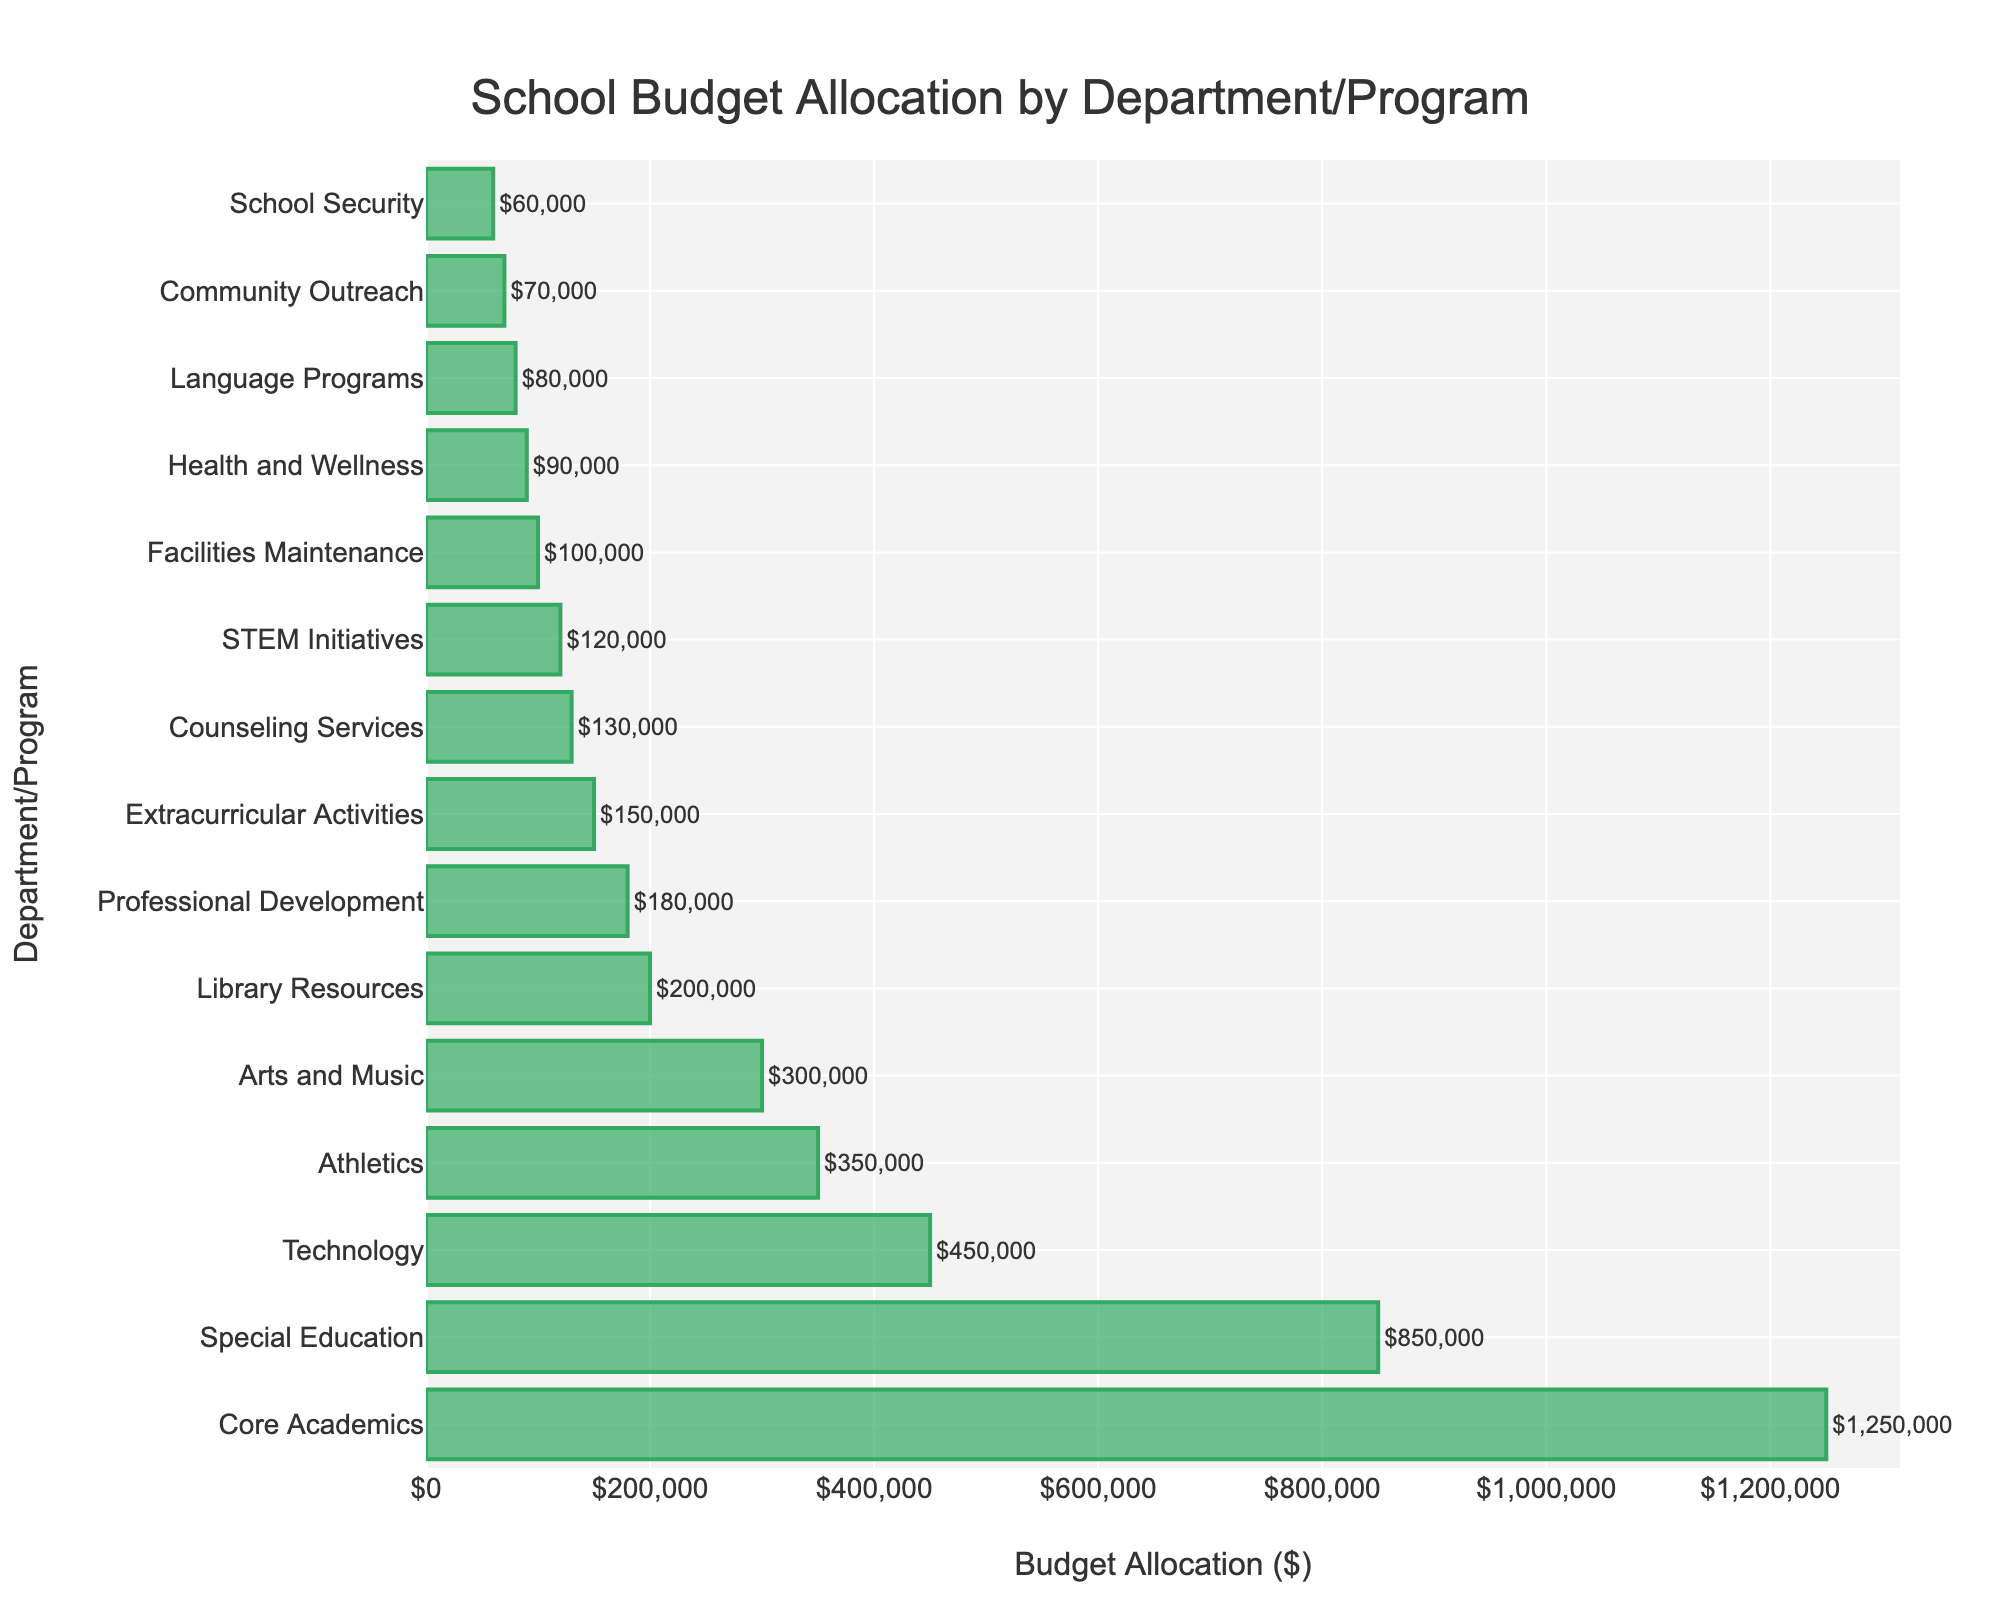Which department received the highest budget allocation? The department with the highest budget allocation is the one with the longest bar in the bar chart. The Core Academics department has the longest bar.
Answer: Core Academics How much is allocated to Special Education compared to Technology? To find out how much more is allocated, subtract the budget for Technology from the budget for Special Education: 850,000 - 450,000 = 400,000.
Answer: 400,000 What's the total budget allocated to Arts and Music, Library Resources, and Professional Development? Add the budget allocations for these departments: 300,000 + 200,000 + 180,000 = 680,000.
Answer: 680,000 Which department has the smallest budget allocation? The department with the smallest budget allocation is the one with the shortest bar in the bar chart. The School Security department has the shortest bar.
Answer: School Security What is the difference in budget allocation between Athletics and Extracurricular Activities? Subtract the budget for Extracurricular Activities from the budget for Athletics: 350,000 - 150,000 = 200,000.
Answer: 200,000 Is the budget allocation for Health and Wellness greater than Language Programs? Compare the lengths of the bars for Health and Wellness and Language Programs. Health and Wellness has a longer bar, indicating a higher budget allocation.
Answer: Yes What is the combined budget for STEM Initiatives and Community Outreach? Add the budget allocations for these departments: 120,000 + 70,000 = 190,000.
Answer: 190,000 How does the budget for Counseling Services compare to Library Resources? Compare the lengths of the bars for Counseling Services (130,000) and Library Resources (200,000). Counseling Services has a shorter bar.
Answer: Counseling Services has a smaller budget allocation Which departments have a budget allocation of less than 100,000? Identify bars with lengths corresponding to budget allocations less than 100,000. These are Facilities Maintenance, Health and Wellness, Language Programs, Community Outreach, and School Security.
Answer: Facilities Maintenance, Health and Wellness, Language Programs, Community Outreach, School Security 